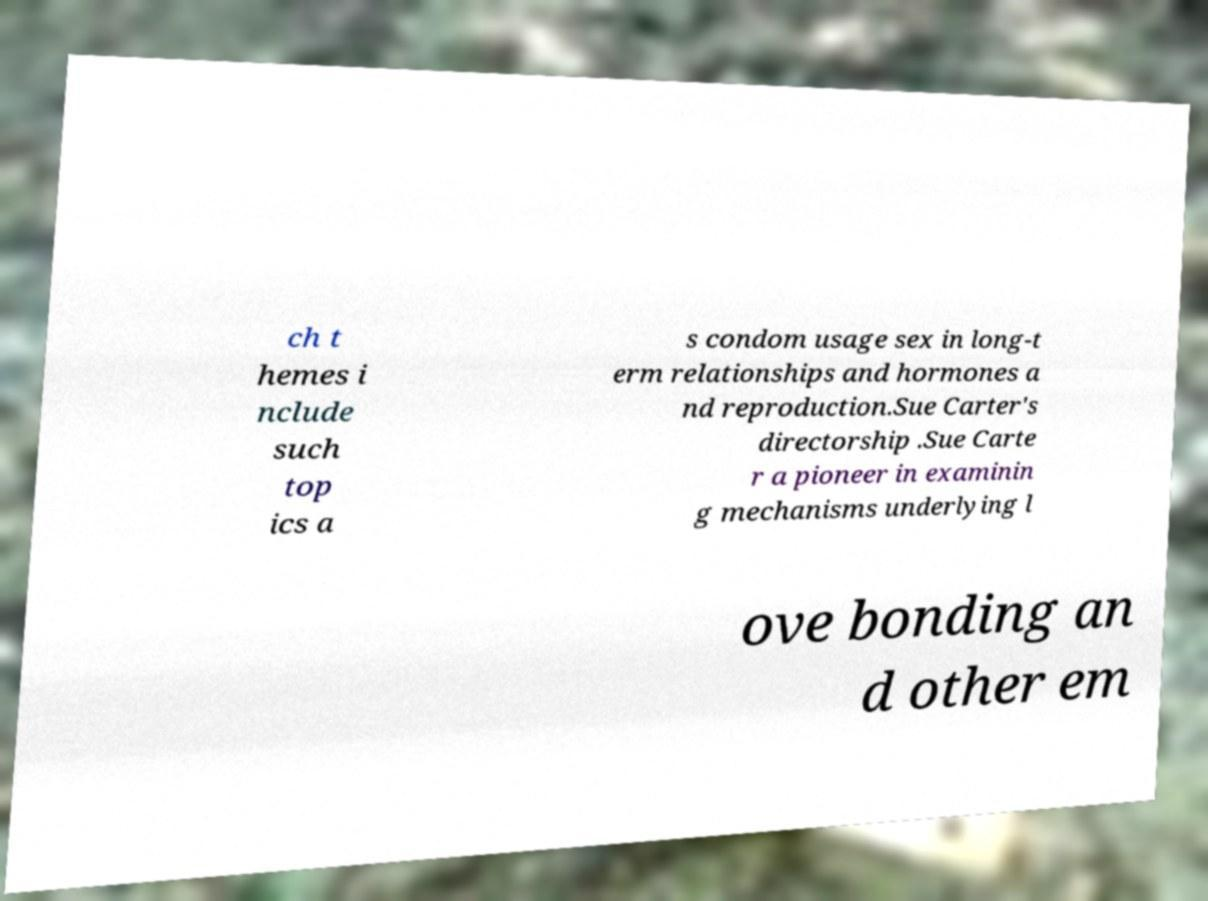Can you accurately transcribe the text from the provided image for me? ch t hemes i nclude such top ics a s condom usage sex in long-t erm relationships and hormones a nd reproduction.Sue Carter's directorship .Sue Carte r a pioneer in examinin g mechanisms underlying l ove bonding an d other em 